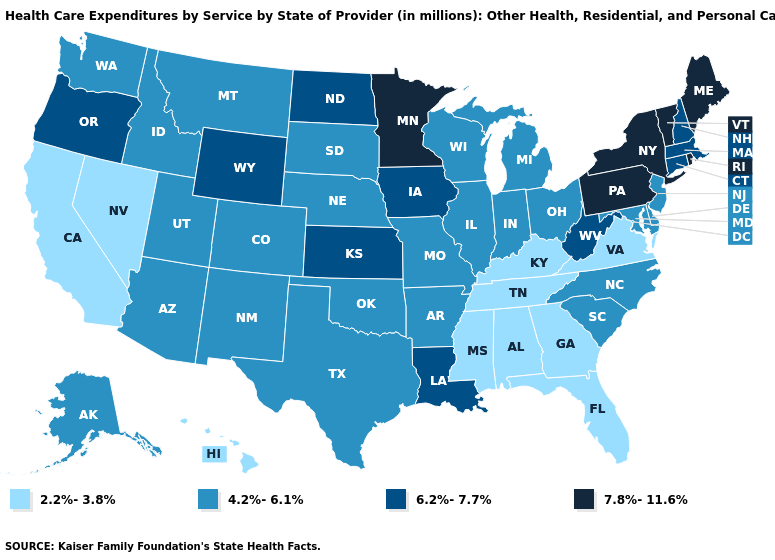How many symbols are there in the legend?
Keep it brief. 4. Which states have the lowest value in the USA?
Short answer required. Alabama, California, Florida, Georgia, Hawaii, Kentucky, Mississippi, Nevada, Tennessee, Virginia. Does Arkansas have the highest value in the South?
Concise answer only. No. Name the states that have a value in the range 4.2%-6.1%?
Be succinct. Alaska, Arizona, Arkansas, Colorado, Delaware, Idaho, Illinois, Indiana, Maryland, Michigan, Missouri, Montana, Nebraska, New Jersey, New Mexico, North Carolina, Ohio, Oklahoma, South Carolina, South Dakota, Texas, Utah, Washington, Wisconsin. Name the states that have a value in the range 6.2%-7.7%?
Write a very short answer. Connecticut, Iowa, Kansas, Louisiana, Massachusetts, New Hampshire, North Dakota, Oregon, West Virginia, Wyoming. Name the states that have a value in the range 4.2%-6.1%?
Quick response, please. Alaska, Arizona, Arkansas, Colorado, Delaware, Idaho, Illinois, Indiana, Maryland, Michigan, Missouri, Montana, Nebraska, New Jersey, New Mexico, North Carolina, Ohio, Oklahoma, South Carolina, South Dakota, Texas, Utah, Washington, Wisconsin. What is the value of South Carolina?
Quick response, please. 4.2%-6.1%. What is the value of Hawaii?
Concise answer only. 2.2%-3.8%. Among the states that border Maryland , does Pennsylvania have the lowest value?
Short answer required. No. Name the states that have a value in the range 4.2%-6.1%?
Answer briefly. Alaska, Arizona, Arkansas, Colorado, Delaware, Idaho, Illinois, Indiana, Maryland, Michigan, Missouri, Montana, Nebraska, New Jersey, New Mexico, North Carolina, Ohio, Oklahoma, South Carolina, South Dakota, Texas, Utah, Washington, Wisconsin. Name the states that have a value in the range 6.2%-7.7%?
Write a very short answer. Connecticut, Iowa, Kansas, Louisiana, Massachusetts, New Hampshire, North Dakota, Oregon, West Virginia, Wyoming. What is the value of California?
Short answer required. 2.2%-3.8%. Does California have the lowest value in the West?
Be succinct. Yes. What is the value of New Mexico?
Quick response, please. 4.2%-6.1%. What is the value of Delaware?
Answer briefly. 4.2%-6.1%. 